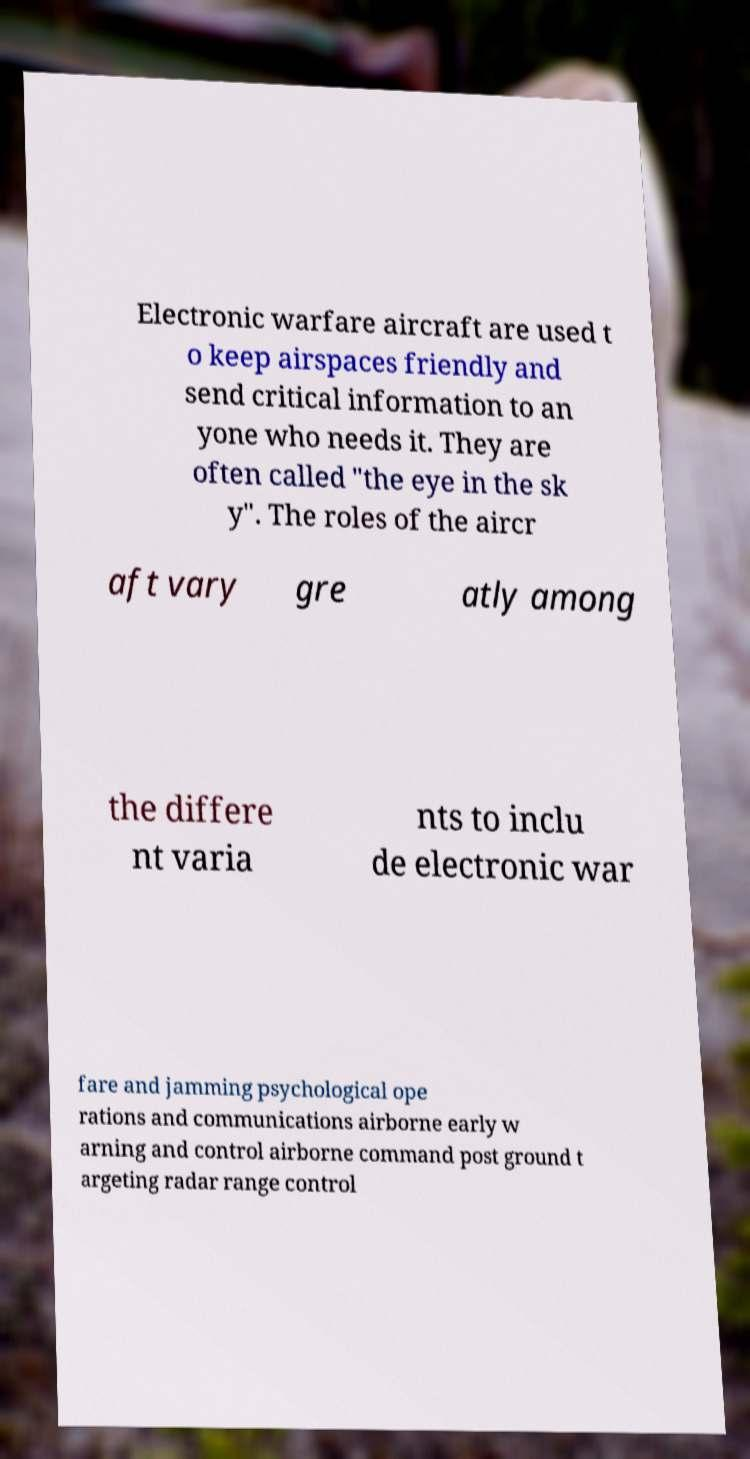Can you accurately transcribe the text from the provided image for me? Electronic warfare aircraft are used t o keep airspaces friendly and send critical information to an yone who needs it. They are often called "the eye in the sk y". The roles of the aircr aft vary gre atly among the differe nt varia nts to inclu de electronic war fare and jamming psychological ope rations and communications airborne early w arning and control airborne command post ground t argeting radar range control 